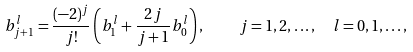Convert formula to latex. <formula><loc_0><loc_0><loc_500><loc_500>b _ { j + 1 } ^ { l } = \frac { ( - 2 ) ^ { j } } { j ! } \left ( b _ { 1 } ^ { l } + \frac { 2 j } { j + 1 } b _ { 0 } ^ { l } \right ) , \quad j = 1 , 2 , \dots , \ \ l = 0 , 1 , \dots ,</formula> 